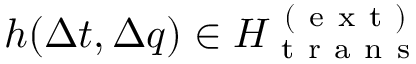Convert formula to latex. <formula><loc_0><loc_0><loc_500><loc_500>h ( \Delta t , \Delta q ) \in H _ { t r a n s } ^ { ( e x t ) }</formula> 